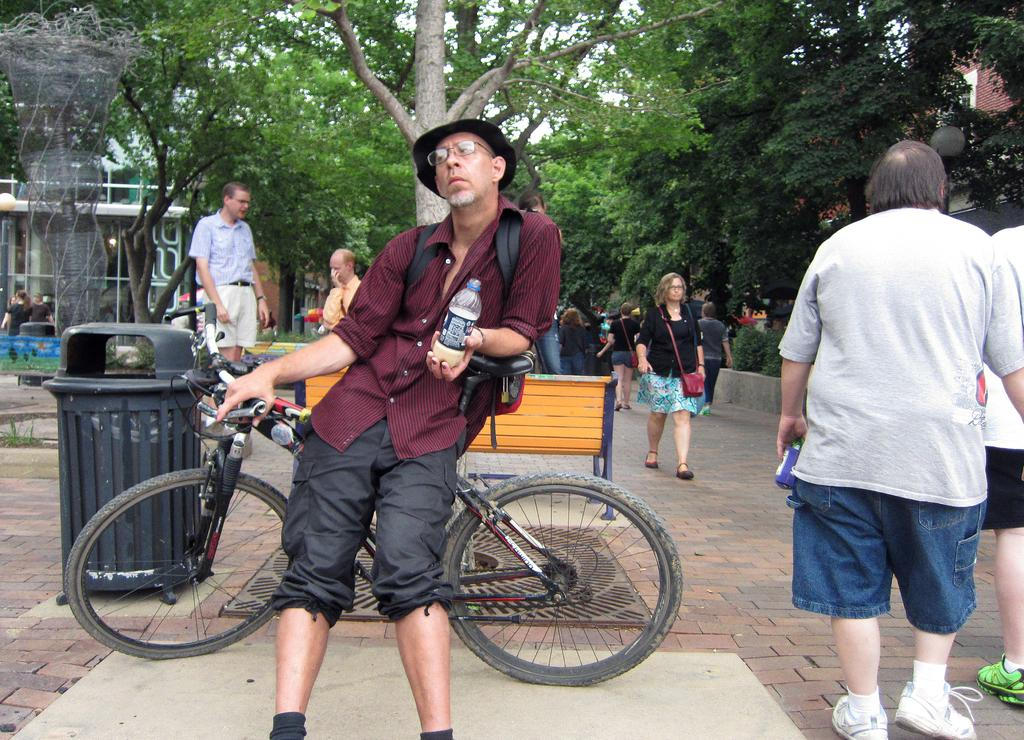What is the person in the image wearing? The person is wearing a red shirt in the image. What is the person holding in the image? The person is holding a bottle in the image. What is the person sitting on in the image? The person is sitting on a bicycle in the image. What can be seen in the background of the image? There is a group of persons and trees in the background of the image. What is the profit of the organization depicted in the image? There is no organization or profit mentioned in the image; it features a person wearing a red shirt, holding a bottle, and sitting on a bicycle. 